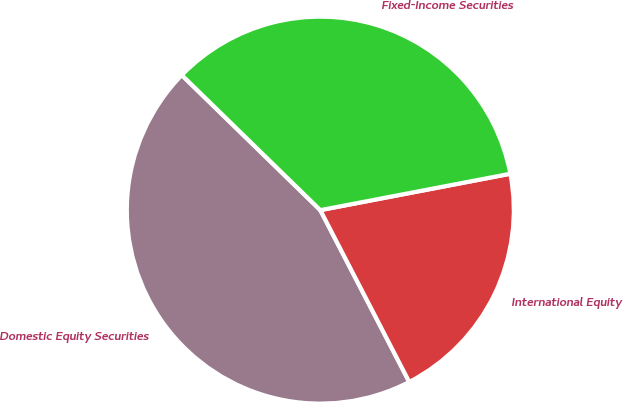<chart> <loc_0><loc_0><loc_500><loc_500><pie_chart><fcel>Domestic Equity Securities<fcel>International Equity<fcel>Fixed-Income Securities<nl><fcel>44.9%<fcel>20.41%<fcel>34.69%<nl></chart> 